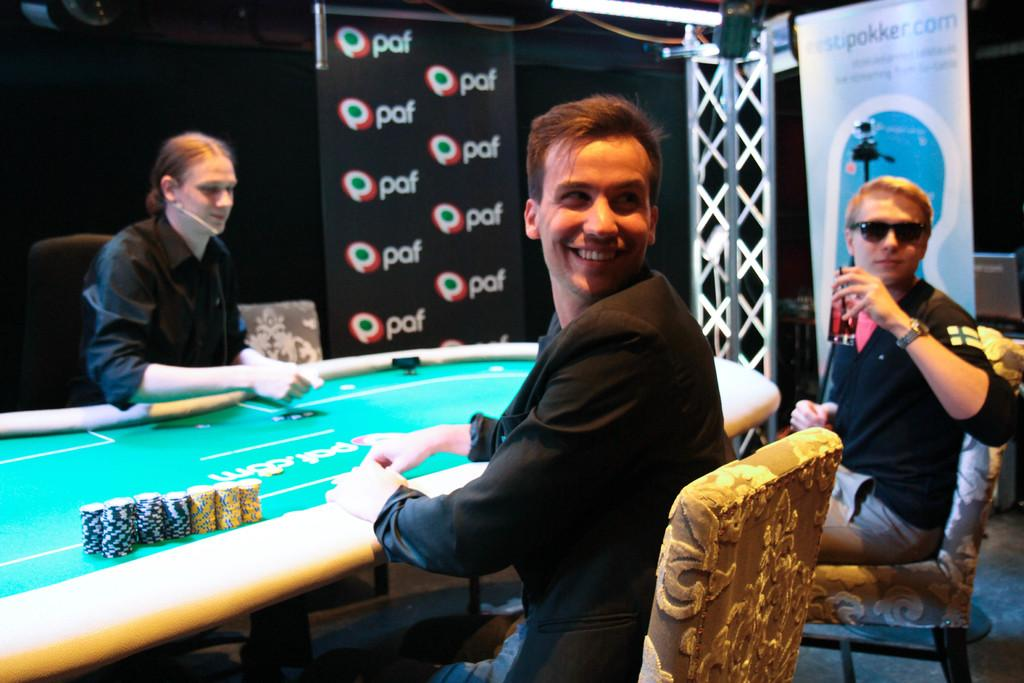How many men are present in the image? There are three men in the image. What are the positions of the men in the image? Two of the men are sitting, and one is standing. Can you describe the facial expression of one of the men? One of the men is smiling. What is one of the men holding in the image? One of the men is holding a glass. What can be seen in the background of the image? There is a banner in the background of the image. What note is the man holding in the image? There is no note present in the image; one of the men is holding a glass. Can you describe the type of wave the men are riding in the image? There are no waves or water activities depicted in the image; it features three men in a setting with a banner in the background. 